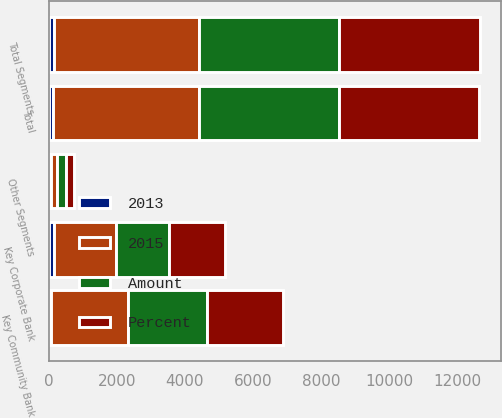Convert chart to OTSL. <chart><loc_0><loc_0><loc_500><loc_500><stacked_bar_chart><ecel><fcel>Key Community Bank<fcel>Key Corporate Bank<fcel>Other Segments<fcel>Total Segments<fcel>Total<nl><fcel>2015<fcel>2275<fcel>1811<fcel>177<fcel>4263<fcel>4256<nl><fcel>Percent<fcel>2215<fcel>1646<fcel>257<fcel>4118<fcel>4114<nl><fcel>Amount<fcel>2315<fcel>1557<fcel>243<fcel>4115<fcel>4114<nl><fcel>2013<fcel>60<fcel>165<fcel>80<fcel>145<fcel>142<nl></chart> 